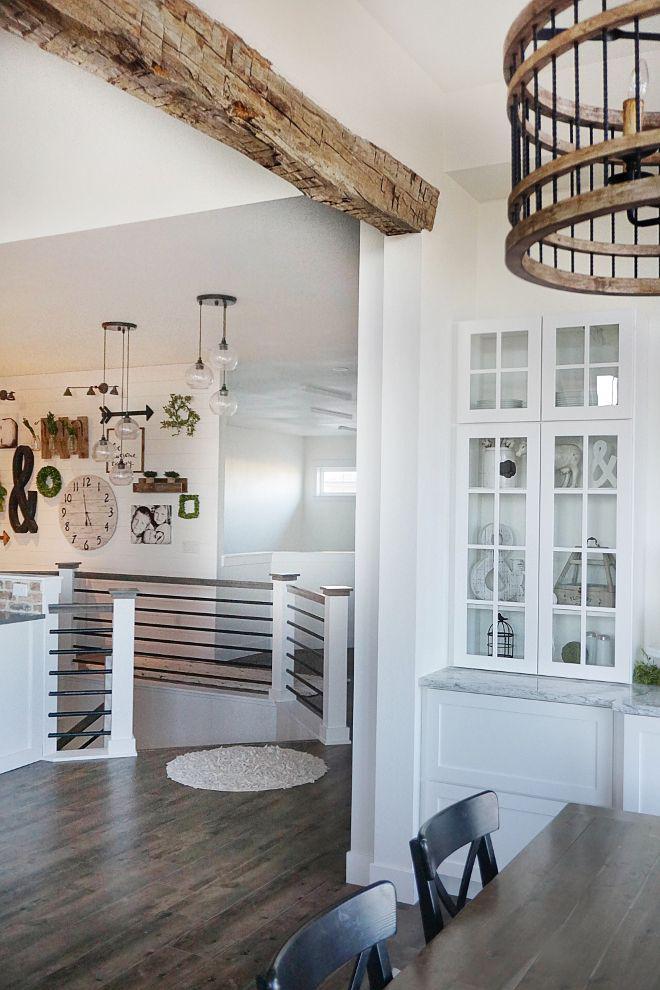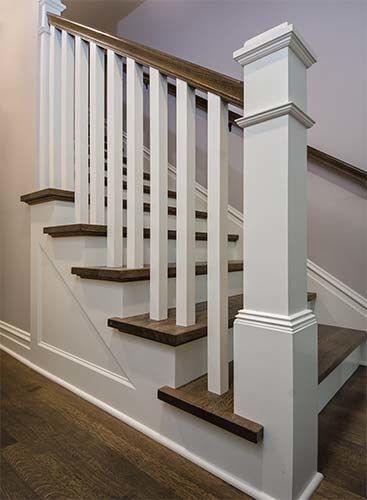The first image is the image on the left, the second image is the image on the right. Considering the images on both sides, is "The left image shows a leftward-ascending staircase with a square light-colored wood-grain post at the bottom." valid? Answer yes or no. No. The first image is the image on the left, the second image is the image on the right. Examine the images to the left and right. Is the description "One of the stair's bannisters ends in a large, light brown colored wooden post." accurate? Answer yes or no. No. 